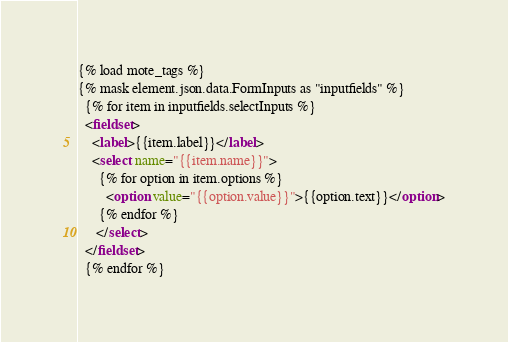<code> <loc_0><loc_0><loc_500><loc_500><_HTML_>
{% load mote_tags %}
{% mask element.json.data.FormInputs as "inputfields" %}
  {% for item in inputfields.selectInputs %}
  <fieldset>
    <label>{{item.label}}</label>
    <select name="{{item.name}}">
      {% for option in item.options %}
        <option value="{{option.value}}">{{option.text}}</option>
      {% endfor %}
     </select>
  </fieldset>
  {% endfor %}

</code> 